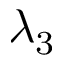<formula> <loc_0><loc_0><loc_500><loc_500>\lambda _ { 3 }</formula> 